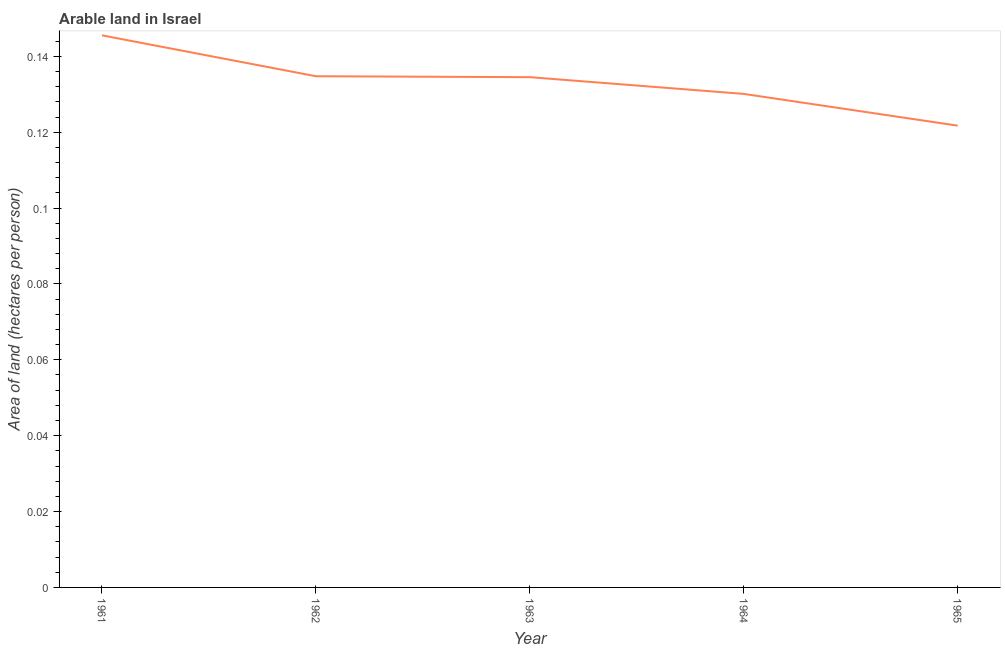What is the area of arable land in 1965?
Give a very brief answer. 0.12. Across all years, what is the maximum area of arable land?
Provide a short and direct response. 0.15. Across all years, what is the minimum area of arable land?
Make the answer very short. 0.12. In which year was the area of arable land minimum?
Offer a very short reply. 1965. What is the sum of the area of arable land?
Provide a short and direct response. 0.67. What is the difference between the area of arable land in 1962 and 1965?
Give a very brief answer. 0.01. What is the average area of arable land per year?
Provide a succinct answer. 0.13. What is the median area of arable land?
Your answer should be compact. 0.13. What is the ratio of the area of arable land in 1962 to that in 1965?
Your answer should be very brief. 1.11. Is the difference between the area of arable land in 1961 and 1965 greater than the difference between any two years?
Offer a very short reply. Yes. What is the difference between the highest and the second highest area of arable land?
Make the answer very short. 0.01. Is the sum of the area of arable land in 1964 and 1965 greater than the maximum area of arable land across all years?
Your answer should be very brief. Yes. What is the difference between the highest and the lowest area of arable land?
Your answer should be compact. 0.02. In how many years, is the area of arable land greater than the average area of arable land taken over all years?
Offer a terse response. 3. How many lines are there?
Offer a very short reply. 1. How many years are there in the graph?
Your answer should be very brief. 5. Does the graph contain any zero values?
Keep it short and to the point. No. What is the title of the graph?
Your response must be concise. Arable land in Israel. What is the label or title of the X-axis?
Make the answer very short. Year. What is the label or title of the Y-axis?
Ensure brevity in your answer.  Area of land (hectares per person). What is the Area of land (hectares per person) in 1961?
Ensure brevity in your answer.  0.15. What is the Area of land (hectares per person) in 1962?
Your answer should be compact. 0.13. What is the Area of land (hectares per person) of 1963?
Your answer should be very brief. 0.13. What is the Area of land (hectares per person) of 1964?
Offer a very short reply. 0.13. What is the Area of land (hectares per person) in 1965?
Give a very brief answer. 0.12. What is the difference between the Area of land (hectares per person) in 1961 and 1962?
Give a very brief answer. 0.01. What is the difference between the Area of land (hectares per person) in 1961 and 1963?
Offer a terse response. 0.01. What is the difference between the Area of land (hectares per person) in 1961 and 1964?
Offer a very short reply. 0.02. What is the difference between the Area of land (hectares per person) in 1961 and 1965?
Give a very brief answer. 0.02. What is the difference between the Area of land (hectares per person) in 1962 and 1963?
Your answer should be very brief. 0. What is the difference between the Area of land (hectares per person) in 1962 and 1964?
Offer a terse response. 0. What is the difference between the Area of land (hectares per person) in 1962 and 1965?
Offer a very short reply. 0.01. What is the difference between the Area of land (hectares per person) in 1963 and 1964?
Keep it short and to the point. 0. What is the difference between the Area of land (hectares per person) in 1963 and 1965?
Your response must be concise. 0.01. What is the difference between the Area of land (hectares per person) in 1964 and 1965?
Offer a very short reply. 0.01. What is the ratio of the Area of land (hectares per person) in 1961 to that in 1963?
Your answer should be compact. 1.08. What is the ratio of the Area of land (hectares per person) in 1961 to that in 1964?
Keep it short and to the point. 1.12. What is the ratio of the Area of land (hectares per person) in 1961 to that in 1965?
Offer a very short reply. 1.2. What is the ratio of the Area of land (hectares per person) in 1962 to that in 1963?
Offer a very short reply. 1. What is the ratio of the Area of land (hectares per person) in 1962 to that in 1964?
Offer a terse response. 1.04. What is the ratio of the Area of land (hectares per person) in 1962 to that in 1965?
Give a very brief answer. 1.11. What is the ratio of the Area of land (hectares per person) in 1963 to that in 1964?
Your response must be concise. 1.03. What is the ratio of the Area of land (hectares per person) in 1963 to that in 1965?
Keep it short and to the point. 1.1. What is the ratio of the Area of land (hectares per person) in 1964 to that in 1965?
Offer a very short reply. 1.07. 